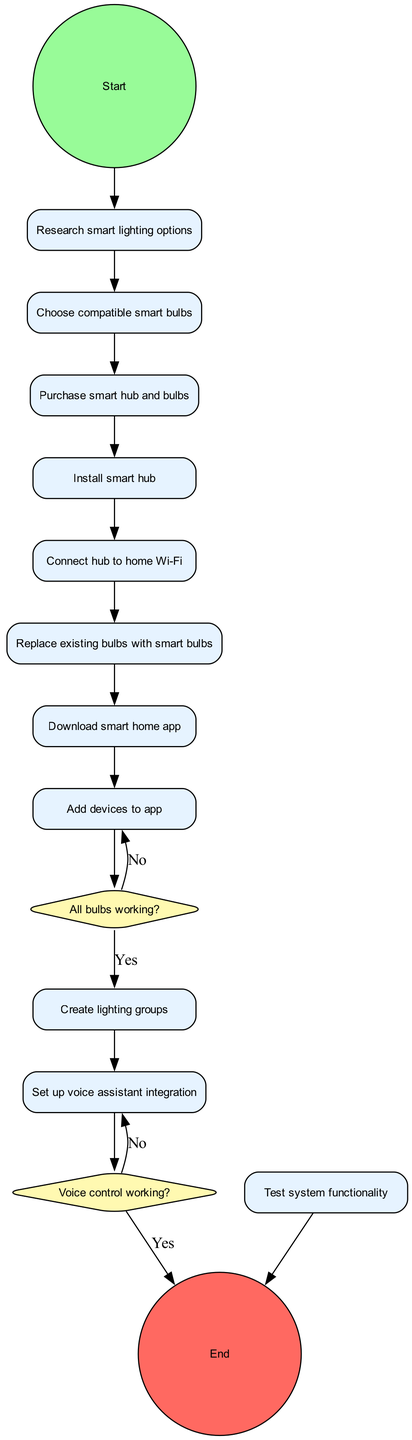What is the first activity to be performed? According to the diagram, the flow starts at the "Start" node, which connects to the first activity, "Research smart lighting options."
Answer: Research smart lighting options How many activities are there in total? The diagram lists a sequence of activities before reaching the decisions and concludes at the "End" node. There are 11 activities, starting from "Research smart lighting options" to "Test system functionality."
Answer: 11 What follows after connecting the hub to home Wi-Fi? Following the connection of the hub to home Wi-Fi, the next activity is "Replace existing bulbs with smart bulbs."
Answer: Replace existing bulbs with smart bulbs What happens if not all bulbs are working? The diagram shows that if not all bulbs are working (the answer is "No" to the decision), the next step would be to "Troubleshoot connections."
Answer: Troubleshoot connections How many decisions are present in the diagram? There are two decisions in the diagram regarding bulb functionality and voice control capability, both of which involve assessing the success of prior activities.
Answer: 2 What is the final step if voice control is not working? If voice control is not working, the next step indicated in the flow is to "Reconfigure voice assistant." This is the response to the "No" outcome of the decision about voice control.
Answer: Reconfigure voice assistant Which activity comes immediately before testing system functionality? The activity immediately preceding "Test system functionality" is "Add devices to app," followed by the final verification step.
Answer: Add devices to app What action must be taken after "Set up voice assistant integration" if voice control is unsuccessful? If voice control is unsuccessful after setting up the voice assistant, the diagram directs to "Reconfigure voice assistant" as the next step.
Answer: Reconfigure voice assistant How do you know you need to troubleshoot connections? The need to "Troubleshoot connections" arises from the decision node questioning if all bulbs are working, leading to that action if the answer is "No."
Answer: Troubleshoot connections 